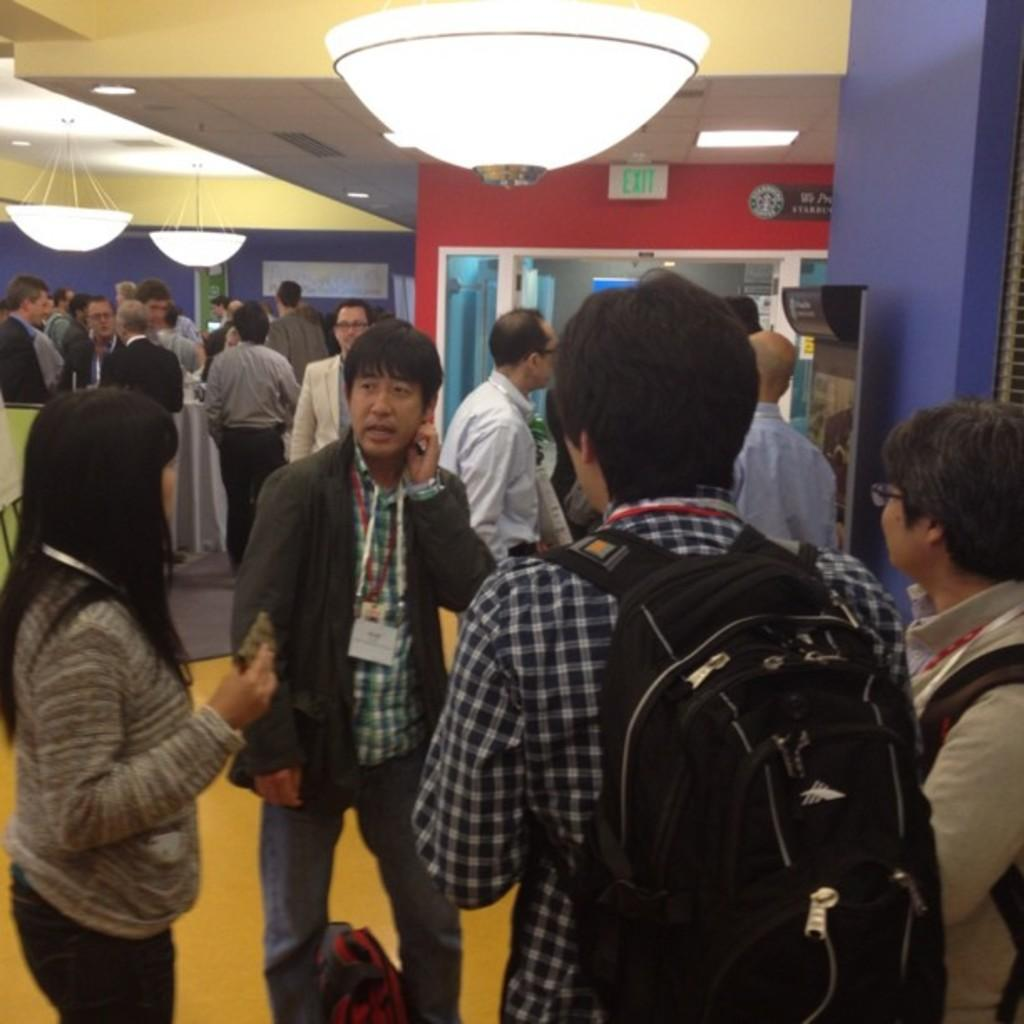How many persons are visible in the image? There are persons standing in the image. What surface are the persons standing on? The persons are standing on the floor. What type of signage is present in the image? There is a sign board in the image. What type of lighting is present in the image? There are chandeliers and electric lights in the image. Can you see any notebooks floating on the lake in the image? There is no lake or notebook present in the image. What type of pancake is being served at the event in the image? There is no event or pancake present in the image. 